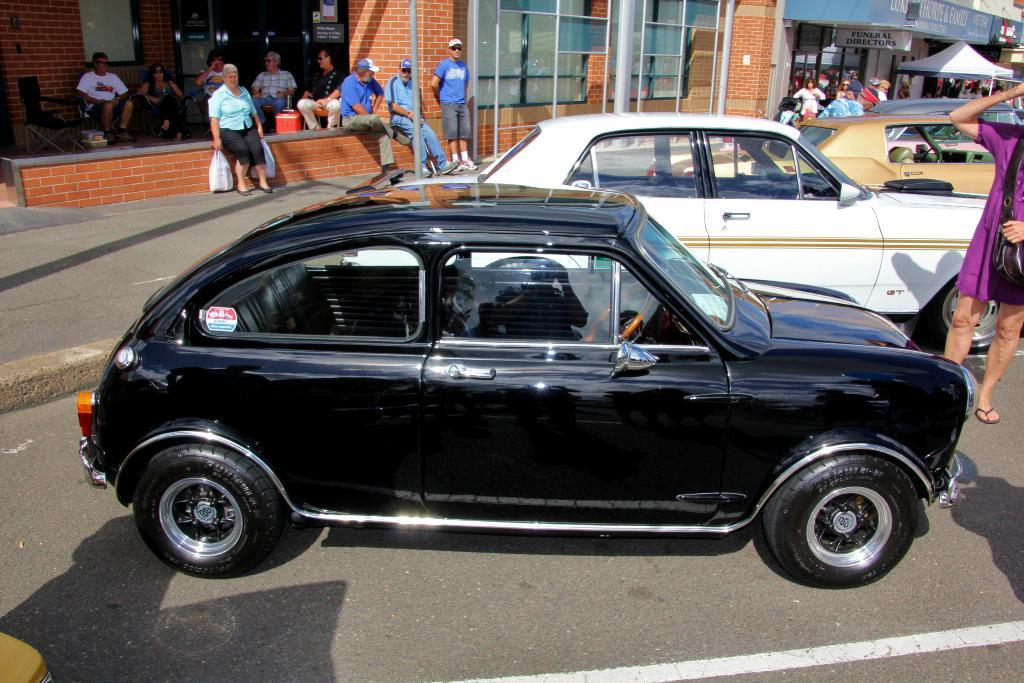What type of vehicles can be seen in the image? There are cars in the image. Who or what else is present in the image? There are people in the image. What structures can be seen in the image? There are buildings in the image. What type of wine is being served at the car dealership in the image? There is no mention of wine or a car dealership in the image. 